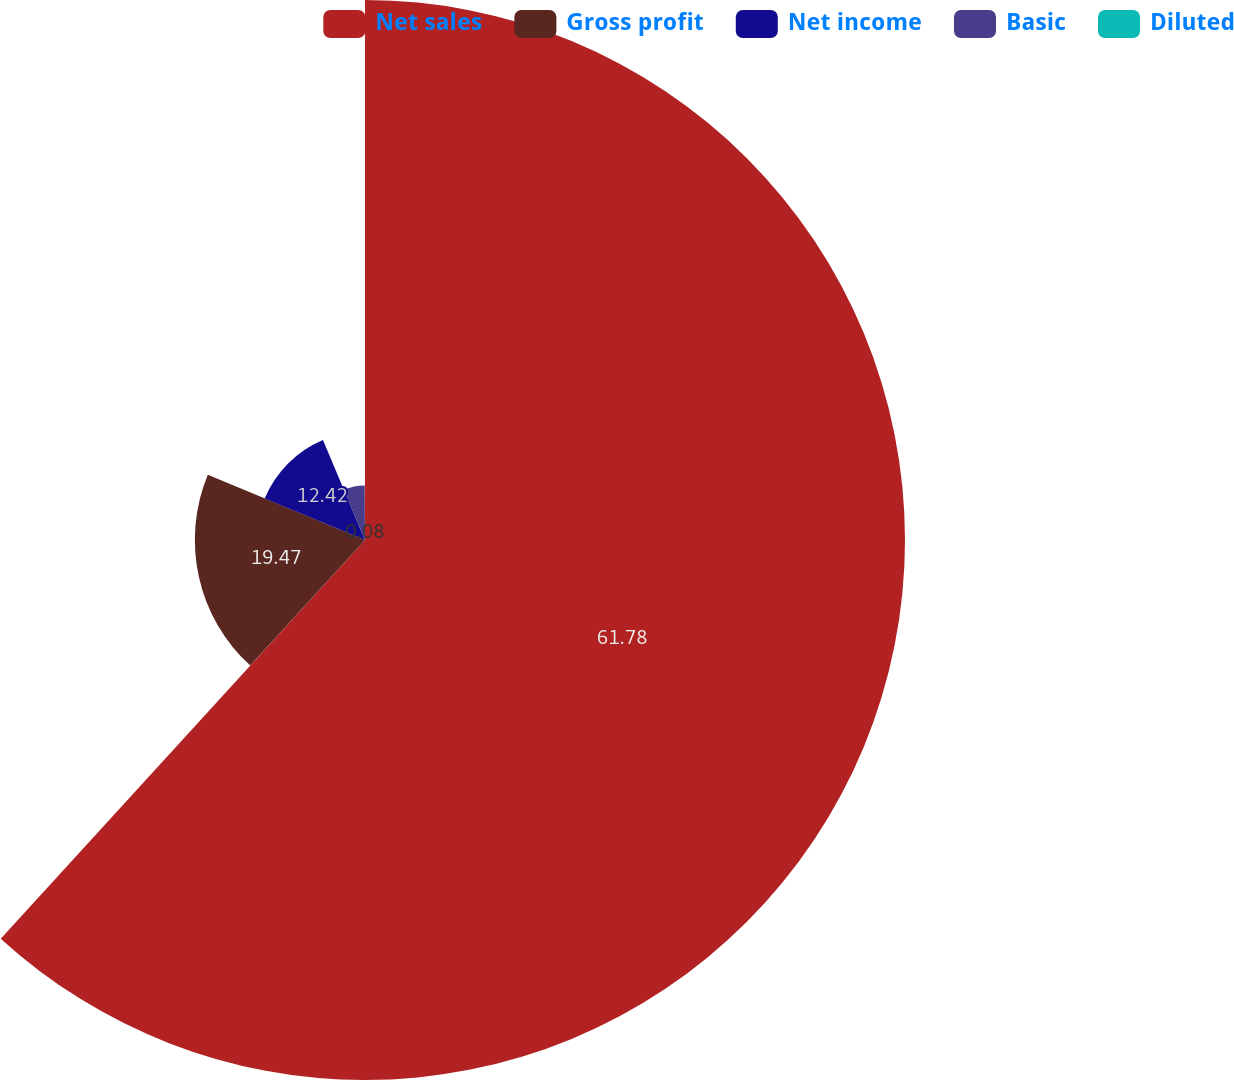Convert chart. <chart><loc_0><loc_0><loc_500><loc_500><pie_chart><fcel>Net sales<fcel>Gross profit<fcel>Net income<fcel>Basic<fcel>Diluted<nl><fcel>61.79%<fcel>19.47%<fcel>12.42%<fcel>6.25%<fcel>0.08%<nl></chart> 